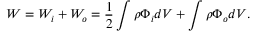<formula> <loc_0><loc_0><loc_500><loc_500>W = W _ { i } + W _ { o } = \frac { 1 } { 2 } \int \rho \Phi _ { i } d V + \int \rho \Phi _ { o } d V .</formula> 